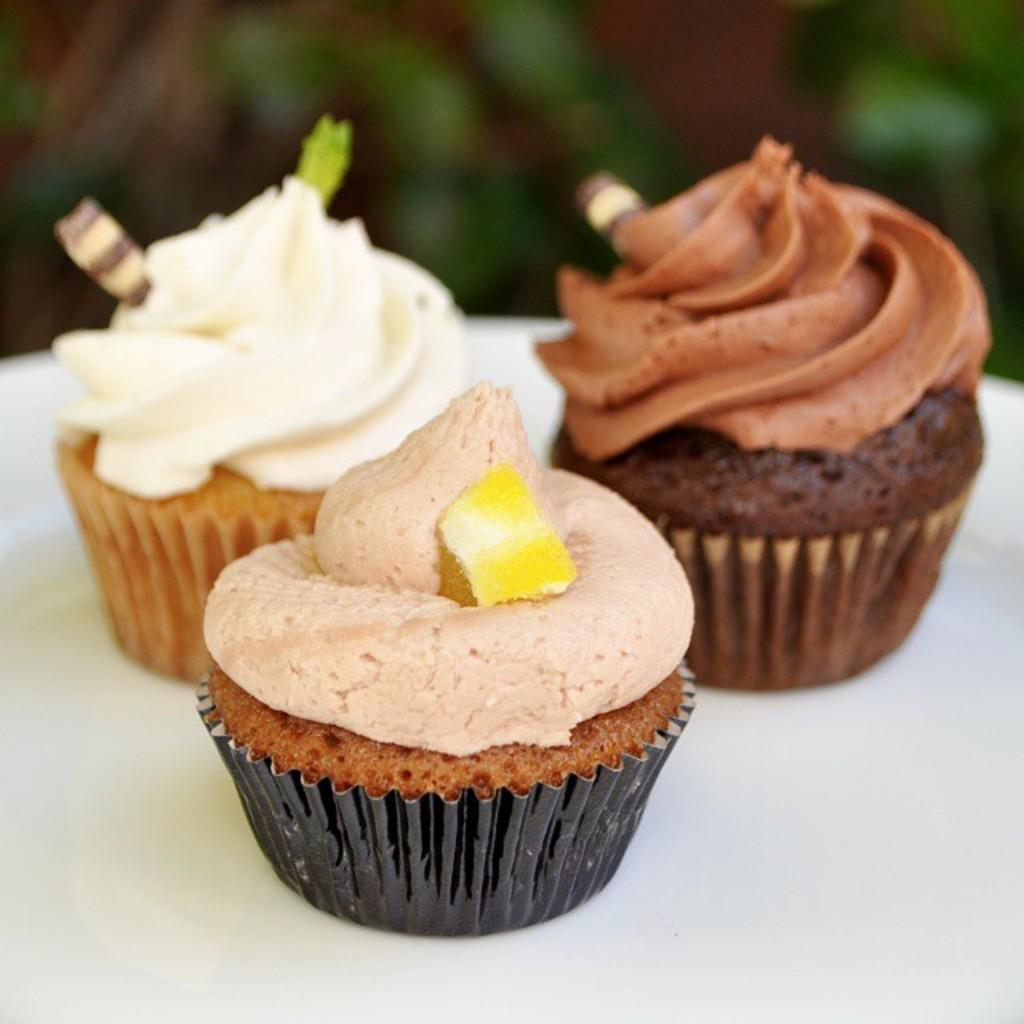What is the main color of the surface in the image? The main color of the surface in the image is white. What is placed on the white surface? There are three cupcakes on the white surface. How many different colors of cream are on the cupcakes? Each cupcake has a different colored cream. What is the brother of the turkey doing in the image? There is no turkey or brother present in the image; it only features a white surface with three cupcakes. 